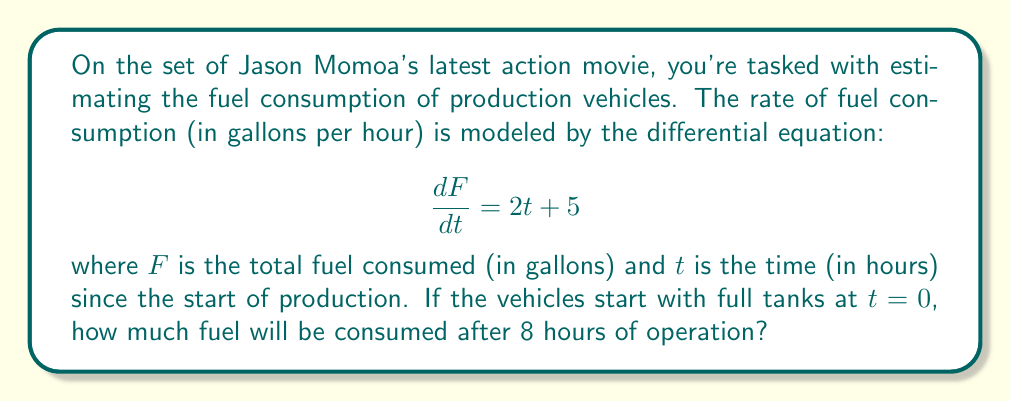Provide a solution to this math problem. To solve this problem, we need to integrate the given differential equation:

1) The differential equation is:
   $$\frac{dF}{dt} = 2t + 5$$

2) To find the total fuel consumed, we need to integrate both sides with respect to $t$:
   $$\int \frac{dF}{dt} dt = \int (2t + 5) dt$$

3) The left side simplifies to $F$, and we integrate the right side:
   $$F = \int (2t + 5) dt = t^2 + 5t + C$$

4) We can find the constant of integration $C$ using the initial condition. At $t=0$, $F=0$ (full tanks):
   $$0 = 0^2 + 5(0) + C$$
   $$C = 0$$

5) So our function for fuel consumption is:
   $$F(t) = t^2 + 5t$$

6) To find the fuel consumed after 8 hours, we evaluate $F(8)$:
   $$F(8) = 8^2 + 5(8) = 64 + 40 = 104$$

Therefore, after 8 hours of operation, the production vehicles will have consumed 104 gallons of fuel.
Answer: 104 gallons 